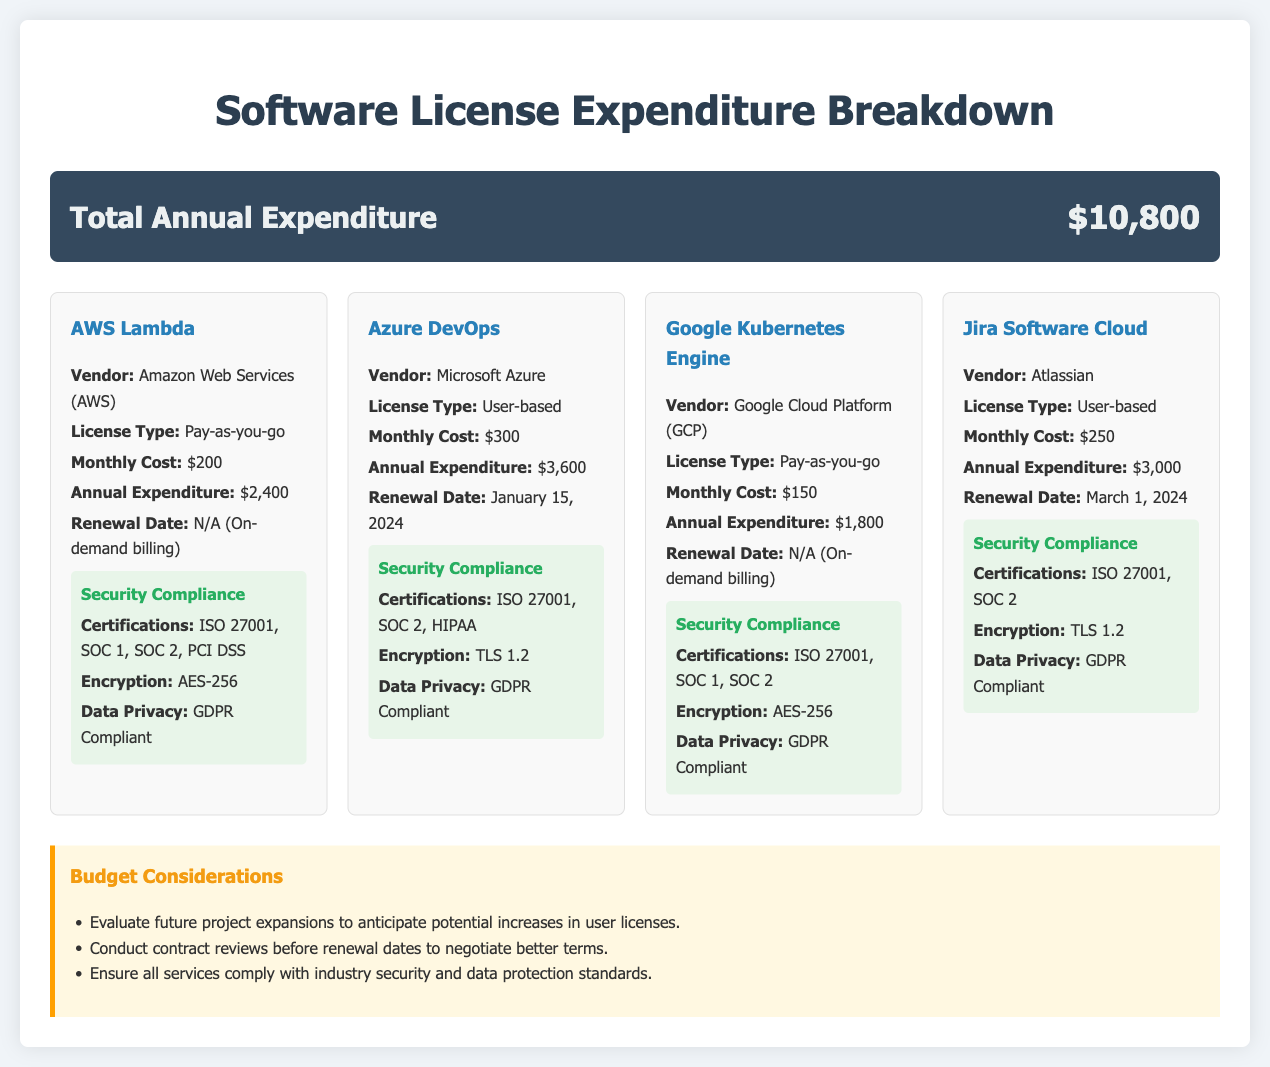What is the total annual expenditure? The total annual expenditure is directly stated in the document as $10,800.
Answer: $10,800 What is the monthly cost for Azure DevOps? The document lists the monthly cost for Azure DevOps as $300.
Answer: $300 When is the renewal date for Jira Software Cloud? The document specifies the renewal date for Jira Software Cloud as March 1, 2024.
Answer: March 1, 2024 What type of license does Google Kubernetes Engine have? The document states that Google Kubernetes Engine has a Pay-as-you-go license type.
Answer: Pay-as-you-go Which vendor provides AWS Lambda? The vendor for AWS Lambda is mentioned as Amazon Web Services (AWS).
Answer: Amazon Web Services (AWS) What encryption standard does Azure DevOps use? The document indicates that Azure DevOps uses TLS 1.2 for encryption.
Answer: TLS 1.2 How many services are listed in the document? There are four services detailed in the expenditure breakdown in the document.
Answer: Four What is the annual expenditure for Google Kubernetes Engine? The document shows the annual expenditure for Google Kubernetes Engine as $1,800.
Answer: $1,800 What is one recommended budget consideration? One budget consideration mentioned is to conduct contract reviews before renewal dates.
Answer: Conduct contract reviews before renewal dates 